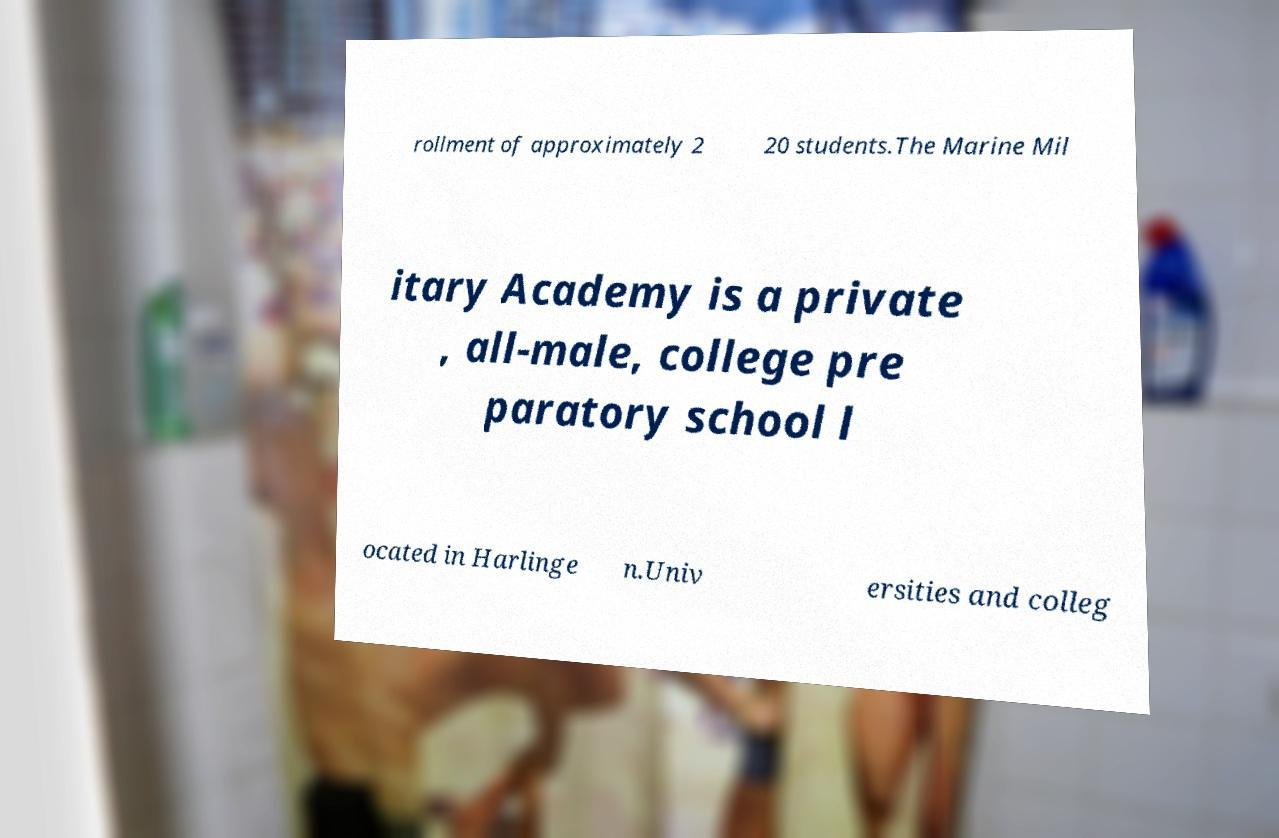Can you read and provide the text displayed in the image?This photo seems to have some interesting text. Can you extract and type it out for me? rollment of approximately 2 20 students.The Marine Mil itary Academy is a private , all-male, college pre paratory school l ocated in Harlinge n.Univ ersities and colleg 